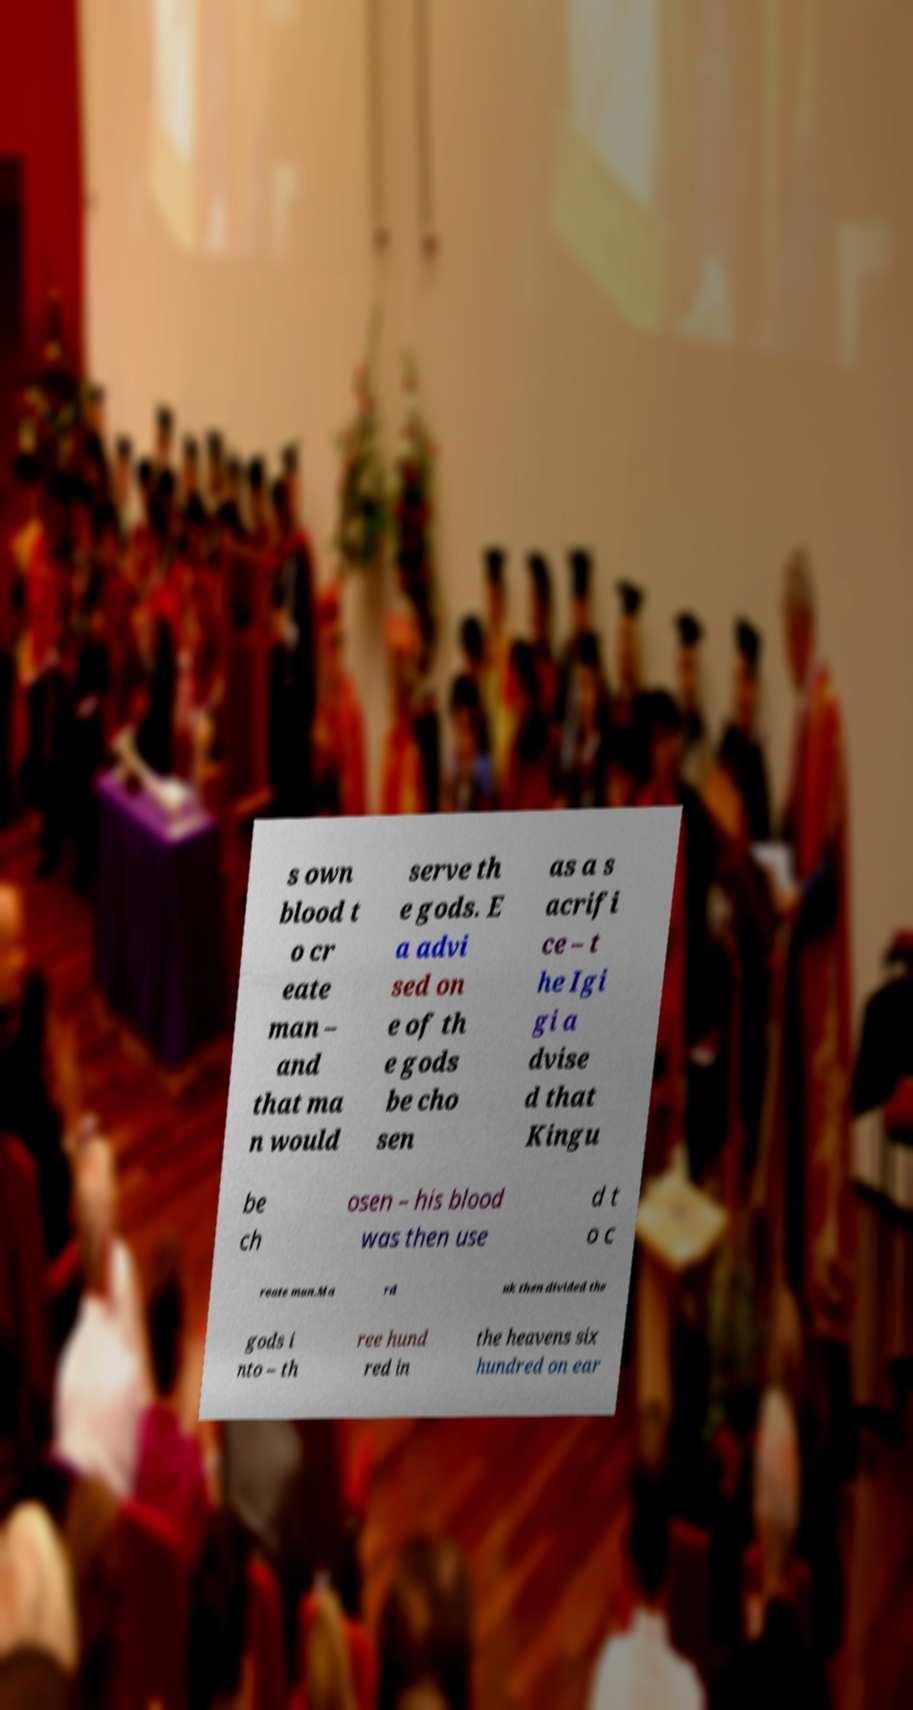Please read and relay the text visible in this image. What does it say? s own blood t o cr eate man – and that ma n would serve th e gods. E a advi sed on e of th e gods be cho sen as a s acrifi ce – t he Igi gi a dvise d that Kingu be ch osen – his blood was then use d t o c reate man.Ma rd uk then divided the gods i nto – th ree hund red in the heavens six hundred on ear 